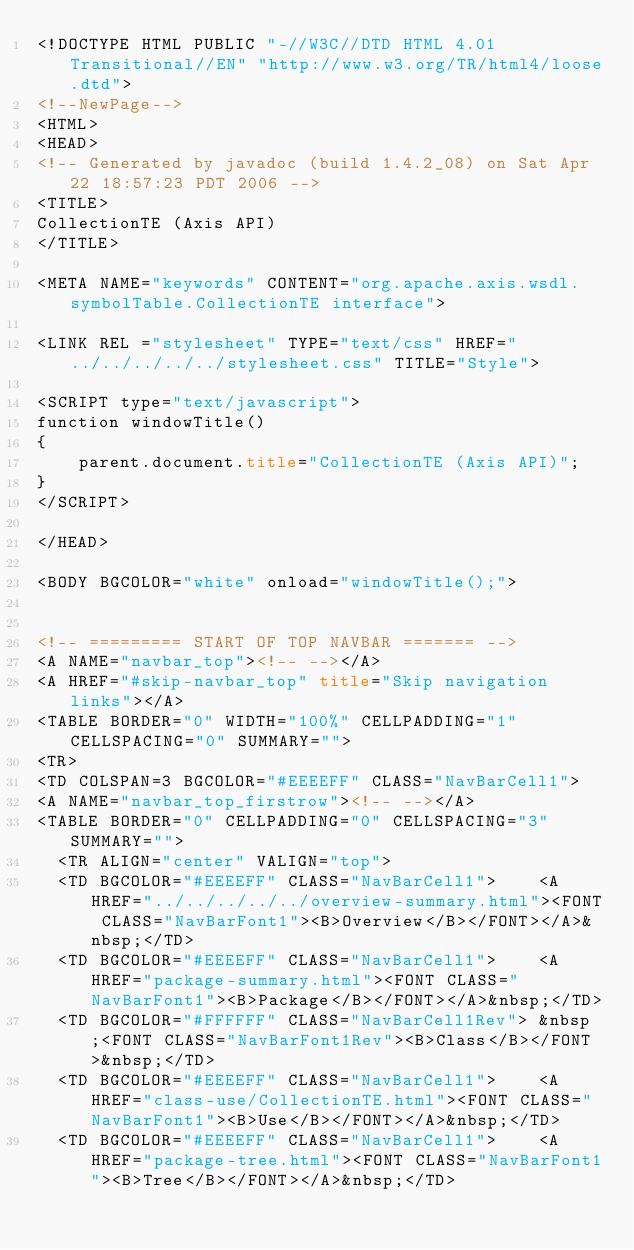<code> <loc_0><loc_0><loc_500><loc_500><_HTML_><!DOCTYPE HTML PUBLIC "-//W3C//DTD HTML 4.01 Transitional//EN" "http://www.w3.org/TR/html4/loose.dtd">
<!--NewPage-->
<HTML>
<HEAD>
<!-- Generated by javadoc (build 1.4.2_08) on Sat Apr 22 18:57:23 PDT 2006 -->
<TITLE>
CollectionTE (Axis API)
</TITLE>

<META NAME="keywords" CONTENT="org.apache.axis.wsdl.symbolTable.CollectionTE interface">

<LINK REL ="stylesheet" TYPE="text/css" HREF="../../../../../stylesheet.css" TITLE="Style">

<SCRIPT type="text/javascript">
function windowTitle()
{
    parent.document.title="CollectionTE (Axis API)";
}
</SCRIPT>

</HEAD>

<BODY BGCOLOR="white" onload="windowTitle();">


<!-- ========= START OF TOP NAVBAR ======= -->
<A NAME="navbar_top"><!-- --></A>
<A HREF="#skip-navbar_top" title="Skip navigation links"></A>
<TABLE BORDER="0" WIDTH="100%" CELLPADDING="1" CELLSPACING="0" SUMMARY="">
<TR>
<TD COLSPAN=3 BGCOLOR="#EEEEFF" CLASS="NavBarCell1">
<A NAME="navbar_top_firstrow"><!-- --></A>
<TABLE BORDER="0" CELLPADDING="0" CELLSPACING="3" SUMMARY="">
  <TR ALIGN="center" VALIGN="top">
  <TD BGCOLOR="#EEEEFF" CLASS="NavBarCell1">    <A HREF="../../../../../overview-summary.html"><FONT CLASS="NavBarFont1"><B>Overview</B></FONT></A>&nbsp;</TD>
  <TD BGCOLOR="#EEEEFF" CLASS="NavBarCell1">    <A HREF="package-summary.html"><FONT CLASS="NavBarFont1"><B>Package</B></FONT></A>&nbsp;</TD>
  <TD BGCOLOR="#FFFFFF" CLASS="NavBarCell1Rev"> &nbsp;<FONT CLASS="NavBarFont1Rev"><B>Class</B></FONT>&nbsp;</TD>
  <TD BGCOLOR="#EEEEFF" CLASS="NavBarCell1">    <A HREF="class-use/CollectionTE.html"><FONT CLASS="NavBarFont1"><B>Use</B></FONT></A>&nbsp;</TD>
  <TD BGCOLOR="#EEEEFF" CLASS="NavBarCell1">    <A HREF="package-tree.html"><FONT CLASS="NavBarFont1"><B>Tree</B></FONT></A>&nbsp;</TD></code> 